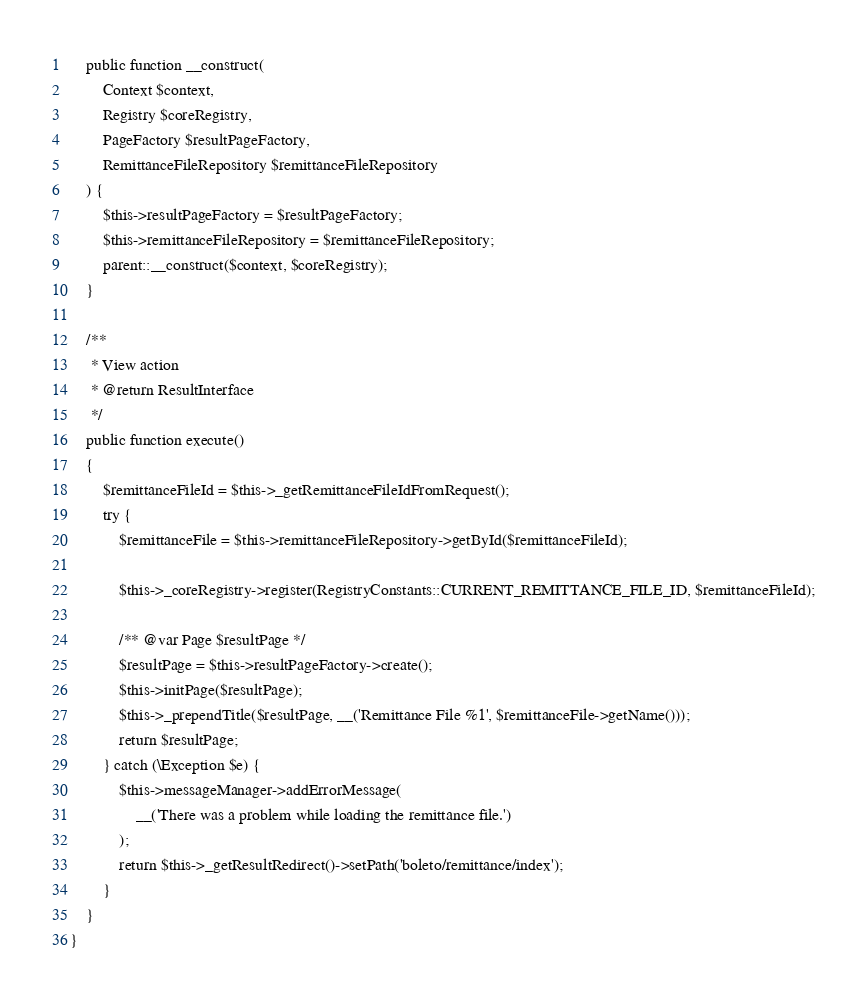Convert code to text. <code><loc_0><loc_0><loc_500><loc_500><_PHP_>    public function __construct(
        Context $context,
        Registry $coreRegistry,
        PageFactory $resultPageFactory,
        RemittanceFileRepository $remittanceFileRepository
    ) {
        $this->resultPageFactory = $resultPageFactory;
        $this->remittanceFileRepository = $remittanceFileRepository;
        parent::__construct($context, $coreRegistry);
    }

    /**
     * View action
     * @return ResultInterface
     */
    public function execute()
    {
        $remittanceFileId = $this->_getRemittanceFileIdFromRequest();
        try {
            $remittanceFile = $this->remittanceFileRepository->getById($remittanceFileId);

            $this->_coreRegistry->register(RegistryConstants::CURRENT_REMITTANCE_FILE_ID, $remittanceFileId);

            /** @var Page $resultPage */
            $resultPage = $this->resultPageFactory->create();
            $this->initPage($resultPage);
            $this->_prependTitle($resultPage, __('Remittance File %1', $remittanceFile->getName()));
            return $resultPage;
        } catch (\Exception $e) {
            $this->messageManager->addErrorMessage(
                __('There was a problem while loading the remittance file.')
            );
            return $this->_getResultRedirect()->setPath('boleto/remittance/index');
        }
    }
}
</code> 